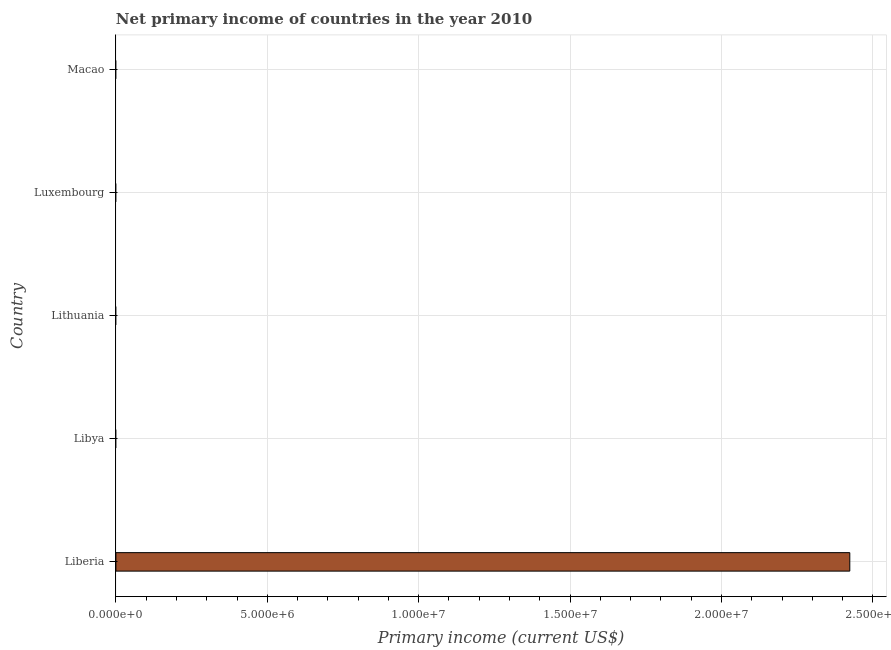Does the graph contain any zero values?
Provide a succinct answer. Yes. Does the graph contain grids?
Keep it short and to the point. Yes. What is the title of the graph?
Provide a short and direct response. Net primary income of countries in the year 2010. What is the label or title of the X-axis?
Give a very brief answer. Primary income (current US$). Across all countries, what is the maximum amount of primary income?
Offer a terse response. 2.42e+07. Across all countries, what is the minimum amount of primary income?
Offer a terse response. 0. In which country was the amount of primary income maximum?
Provide a succinct answer. Liberia. What is the sum of the amount of primary income?
Keep it short and to the point. 2.42e+07. What is the average amount of primary income per country?
Your answer should be very brief. 4.85e+06. What is the median amount of primary income?
Provide a succinct answer. 0. In how many countries, is the amount of primary income greater than 18000000 US$?
Keep it short and to the point. 1. What is the difference between the highest and the lowest amount of primary income?
Your answer should be compact. 2.42e+07. How many bars are there?
Offer a very short reply. 1. Are all the bars in the graph horizontal?
Give a very brief answer. Yes. What is the difference between two consecutive major ticks on the X-axis?
Your answer should be very brief. 5.00e+06. Are the values on the major ticks of X-axis written in scientific E-notation?
Give a very brief answer. Yes. What is the Primary income (current US$) of Liberia?
Give a very brief answer. 2.42e+07. What is the Primary income (current US$) of Libya?
Keep it short and to the point. 0. What is the Primary income (current US$) in Luxembourg?
Give a very brief answer. 0. 